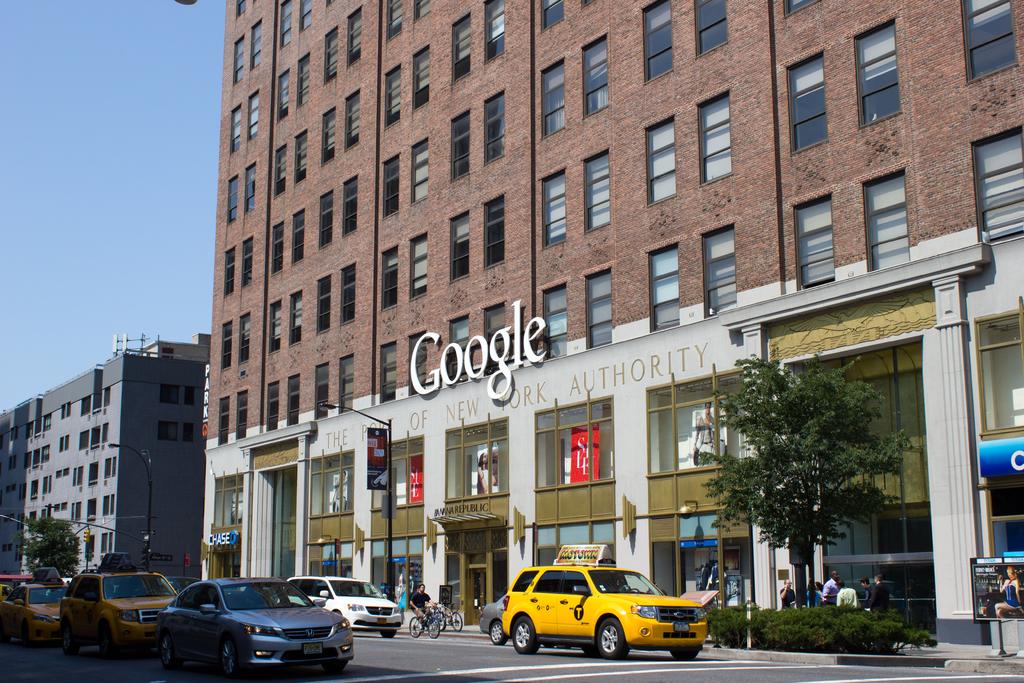Is this google headquarters?
Ensure brevity in your answer.  Yes. What is the name on the sign?
Your response must be concise. Google. 